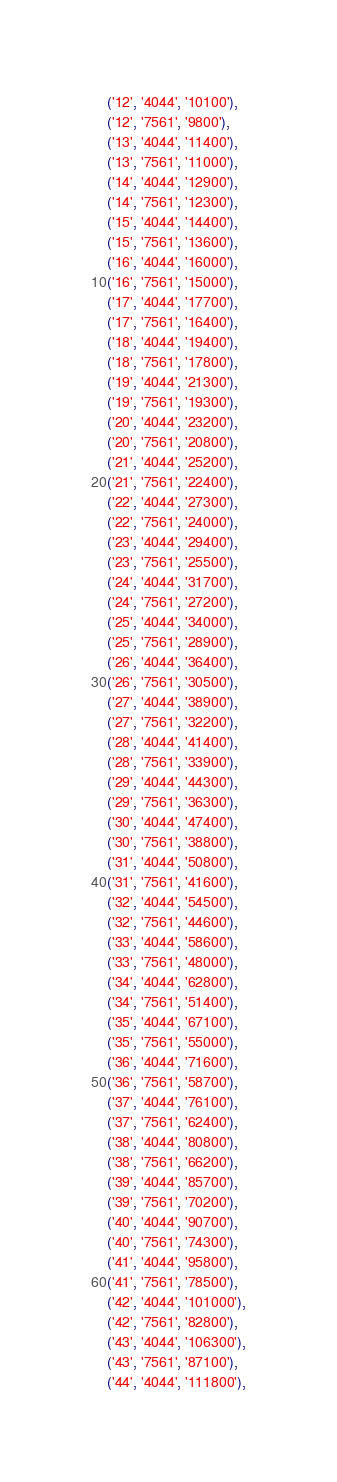Convert code to text. <code><loc_0><loc_0><loc_500><loc_500><_SQL_>('12', '4044', '10100'),
('12', '7561', '9800'),
('13', '4044', '11400'),
('13', '7561', '11000'),
('14', '4044', '12900'),
('14', '7561', '12300'),
('15', '4044', '14400'),
('15', '7561', '13600'),
('16', '4044', '16000'),
('16', '7561', '15000'),
('17', '4044', '17700'),
('17', '7561', '16400'),
('18', '4044', '19400'),
('18', '7561', '17800'),
('19', '4044', '21300'),
('19', '7561', '19300'),
('20', '4044', '23200'),
('20', '7561', '20800'),
('21', '4044', '25200'),
('21', '7561', '22400'),
('22', '4044', '27300'),
('22', '7561', '24000'),
('23', '4044', '29400'),
('23', '7561', '25500'),
('24', '4044', '31700'),
('24', '7561', '27200'),
('25', '4044', '34000'),
('25', '7561', '28900'),
('26', '4044', '36400'),
('26', '7561', '30500'),
('27', '4044', '38900'),
('27', '7561', '32200'),
('28', '4044', '41400'),
('28', '7561', '33900'),
('29', '4044', '44300'),
('29', '7561', '36300'),
('30', '4044', '47400'),
('30', '7561', '38800'),
('31', '4044', '50800'),
('31', '7561', '41600'),
('32', '4044', '54500'),
('32', '7561', '44600'),
('33', '4044', '58600'),
('33', '7561', '48000'),
('34', '4044', '62800'),
('34', '7561', '51400'),
('35', '4044', '67100'),
('35', '7561', '55000'),
('36', '4044', '71600'),
('36', '7561', '58700'),
('37', '4044', '76100'),
('37', '7561', '62400'),
('38', '4044', '80800'),
('38', '7561', '66200'),
('39', '4044', '85700'),
('39', '7561', '70200'),
('40', '4044', '90700'),
('40', '7561', '74300'),
('41', '4044', '95800'),
('41', '7561', '78500'),
('42', '4044', '101000'),
('42', '7561', '82800'),
('43', '4044', '106300'),
('43', '7561', '87100'),
('44', '4044', '111800'),</code> 